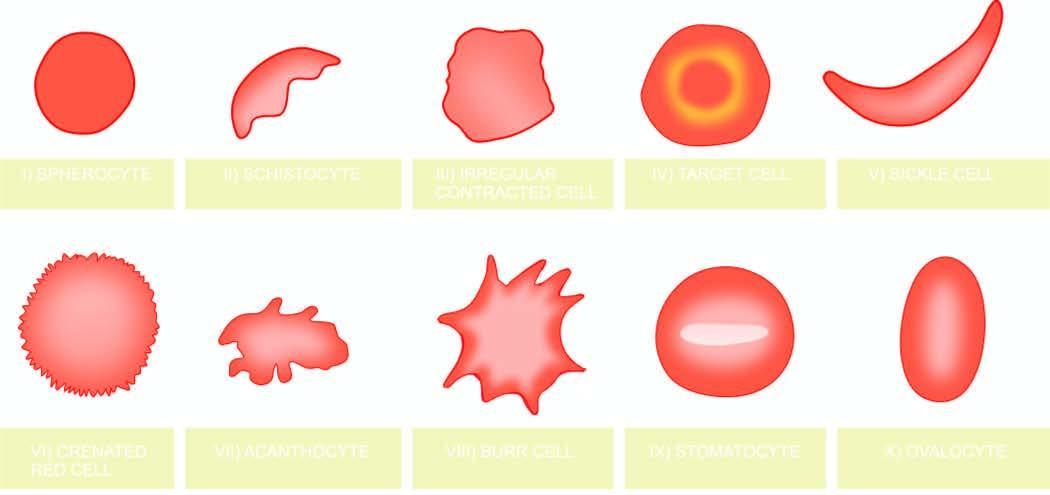do nuclei correspond to the order in which they are described in the text?
Answer the question using a single word or phrase. No 